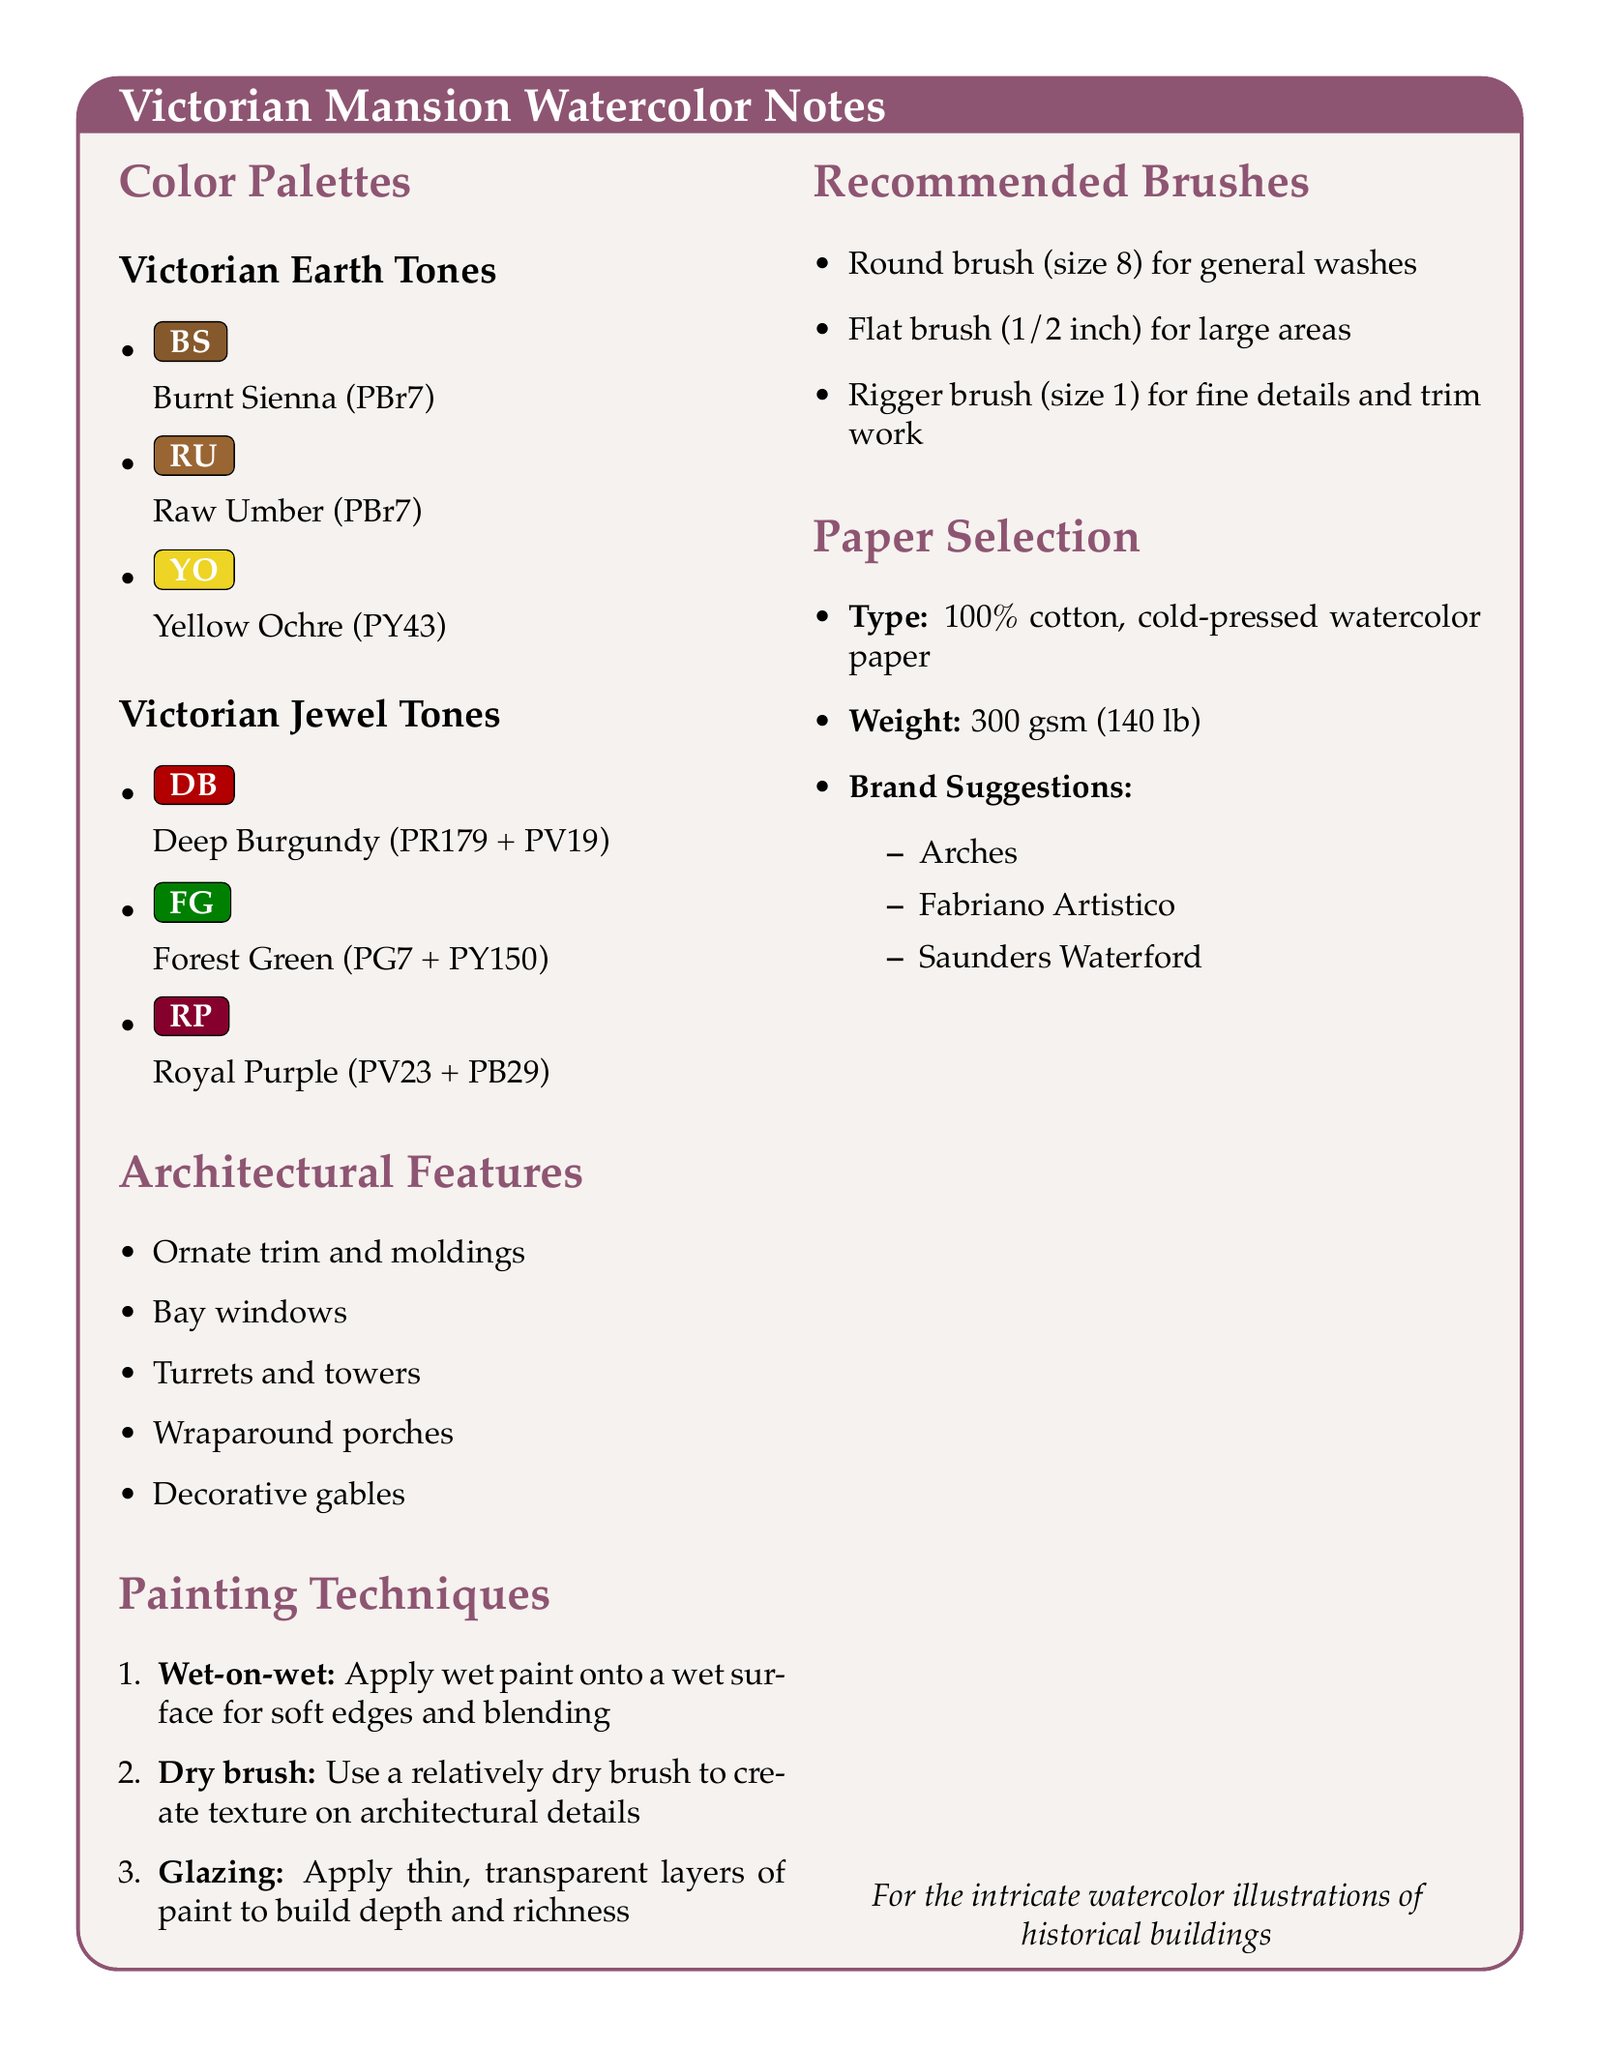What is the pigment for Deep Burgundy? The pigment used for Deep Burgundy includes Perylene Maroon and Quinacridone Rose in a ratio of 2:1.
Answer: PR179 + PV19 What type of watercolor paper is recommended? The recommended paper is 100% cotton, cold-pressed watercolor paper.
Answer: 100% cotton, cold-pressed What is the mixing ratio for Royal Purple? The mixing ratio for Royal Purple is a combination of Dioxazine Violet and Ultramarine Blue.
Answer: 1:1 Name one architectural feature listed in the notes. The notes include several architectural features that characterize Victorian mansions.
Answer: Bay windows What technique is suggested for applying thin, transparent layers of paint? One of the painting techniques described involves layering paint to achieve a specific visual effect.
Answer: Glazing What is the recommended brush size for general washes? A specific brush size is mentioned for general washes in watercolor painting.
Answer: size 8 How many color palettes are suggested in the notes? The notes provide an overview of different color palettes that are suitable for watercolor illustrations.
Answer: Two What color is Burnt Sienna classified as? Within the provided color palettes, Burnt Sienna is identified by a specific classification.
Answer: PBr7 Which brand is suggested for watercolor paper? The document lists recommended brands for cotton, cold-pressed watercolor paper.
Answer: Arches 